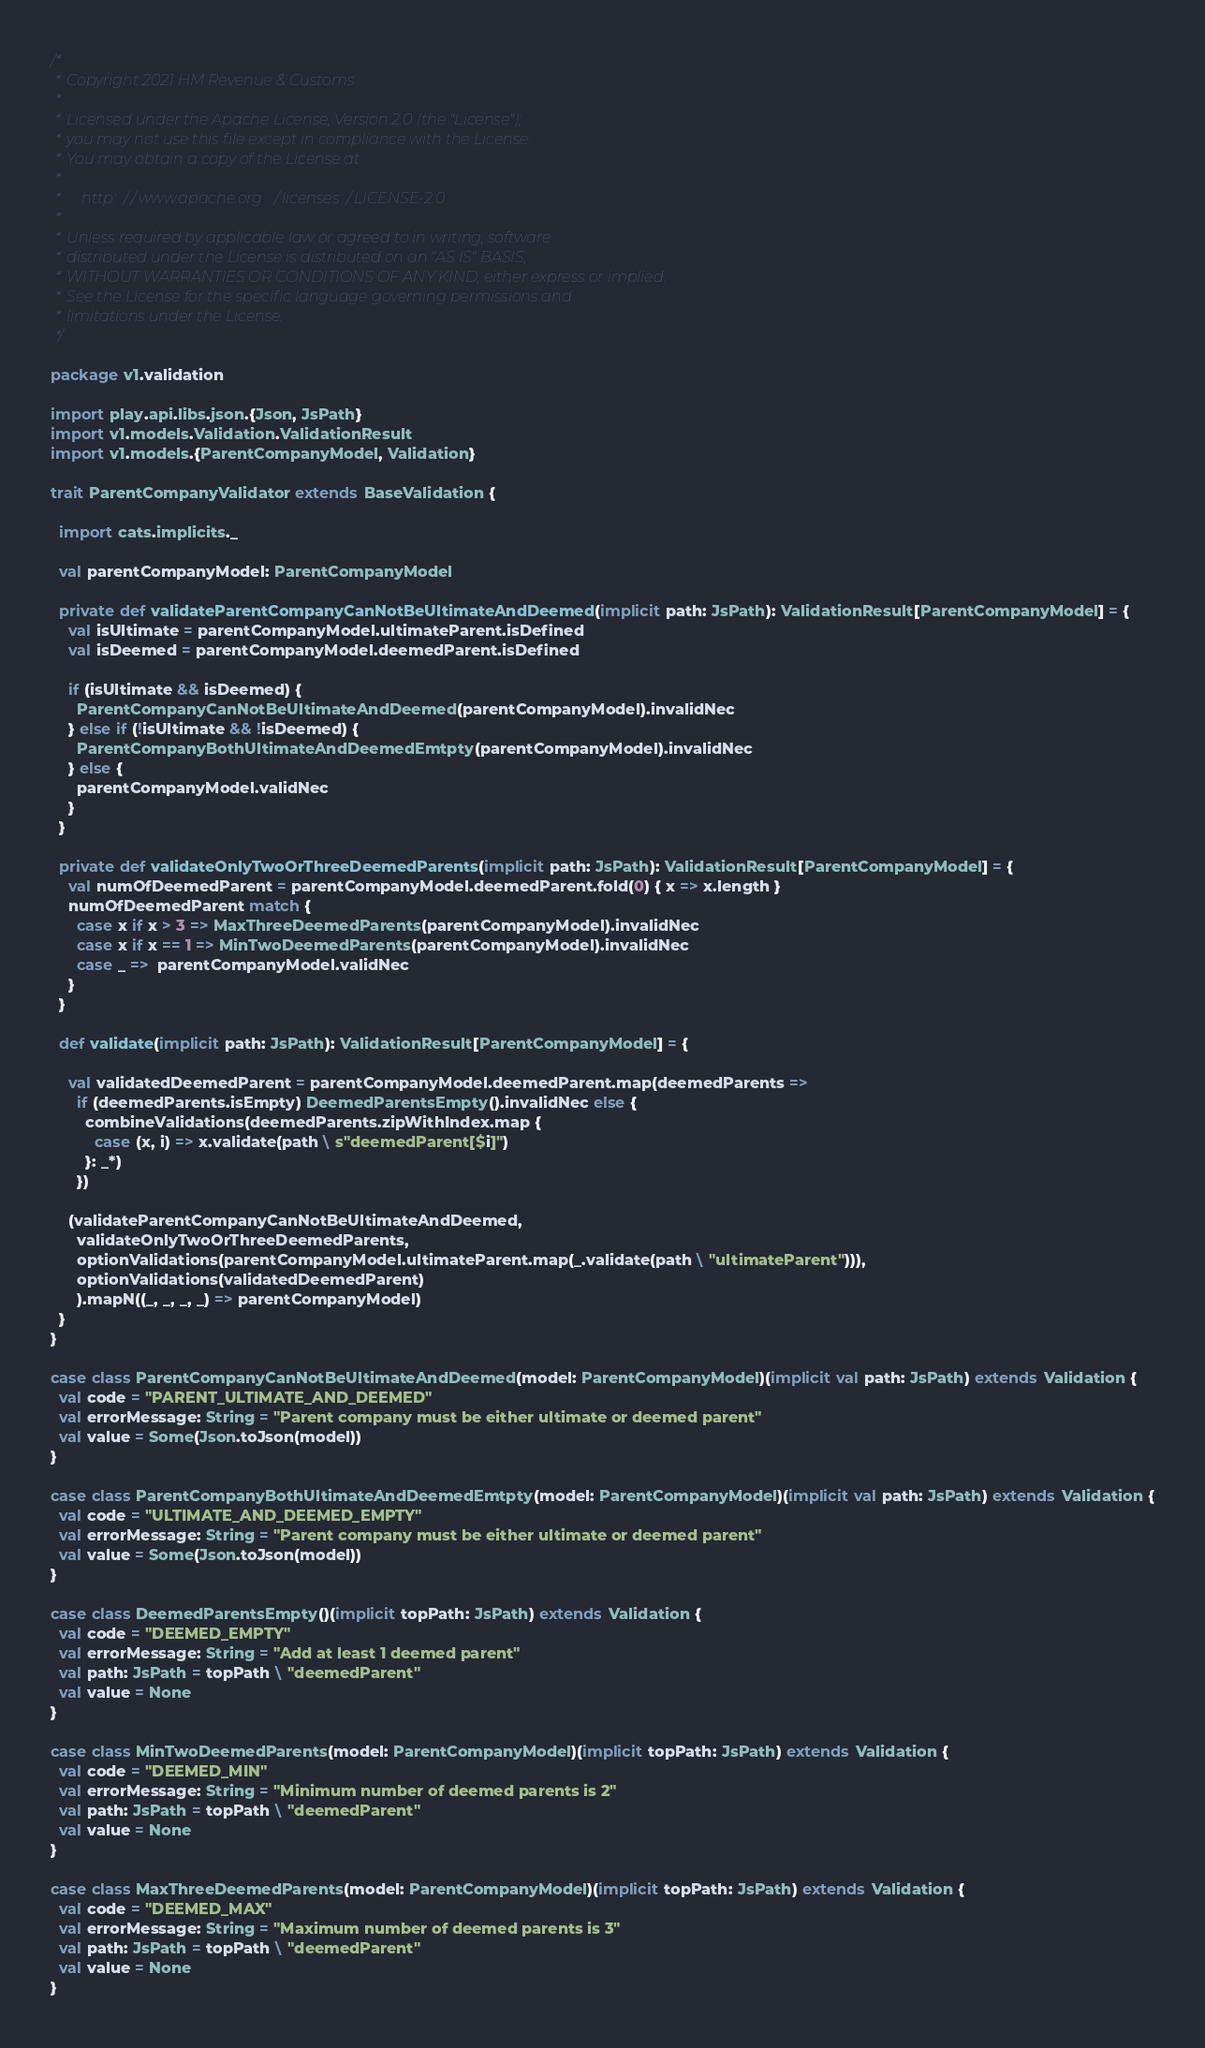Convert code to text. <code><loc_0><loc_0><loc_500><loc_500><_Scala_>/*
 * Copyright 2021 HM Revenue & Customs
 *
 * Licensed under the Apache License, Version 2.0 (the "License");
 * you may not use this file except in compliance with the License.
 * You may obtain a copy of the License at
 *
 *     http://www.apache.org/licenses/LICENSE-2.0
 *
 * Unless required by applicable law or agreed to in writing, software
 * distributed under the License is distributed on an "AS IS" BASIS,
 * WITHOUT WARRANTIES OR CONDITIONS OF ANY KIND, either express or implied.
 * See the License for the specific language governing permissions and
 * limitations under the License.
 */

package v1.validation

import play.api.libs.json.{Json, JsPath}
import v1.models.Validation.ValidationResult
import v1.models.{ParentCompanyModel, Validation}

trait ParentCompanyValidator extends BaseValidation {

  import cats.implicits._

  val parentCompanyModel: ParentCompanyModel

  private def validateParentCompanyCanNotBeUltimateAndDeemed(implicit path: JsPath): ValidationResult[ParentCompanyModel] = {
    val isUltimate = parentCompanyModel.ultimateParent.isDefined
    val isDeemed = parentCompanyModel.deemedParent.isDefined

    if (isUltimate && isDeemed) {
      ParentCompanyCanNotBeUltimateAndDeemed(parentCompanyModel).invalidNec
    } else if (!isUltimate && !isDeemed) {
      ParentCompanyBothUltimateAndDeemedEmtpty(parentCompanyModel).invalidNec
    } else {
      parentCompanyModel.validNec
    }
  }

  private def validateOnlyTwoOrThreeDeemedParents(implicit path: JsPath): ValidationResult[ParentCompanyModel] = {
    val numOfDeemedParent = parentCompanyModel.deemedParent.fold(0) { x => x.length }
    numOfDeemedParent match {
      case x if x > 3 => MaxThreeDeemedParents(parentCompanyModel).invalidNec
      case x if x == 1 => MinTwoDeemedParents(parentCompanyModel).invalidNec
      case _ =>  parentCompanyModel.validNec
    }
  }

  def validate(implicit path: JsPath): ValidationResult[ParentCompanyModel] = {

    val validatedDeemedParent = parentCompanyModel.deemedParent.map(deemedParents =>
      if (deemedParents.isEmpty) DeemedParentsEmpty().invalidNec else {
        combineValidations(deemedParents.zipWithIndex.map {
          case (x, i) => x.validate(path \ s"deemedParent[$i]")
        }: _*)
      })

    (validateParentCompanyCanNotBeUltimateAndDeemed,
      validateOnlyTwoOrThreeDeemedParents,
      optionValidations(parentCompanyModel.ultimateParent.map(_.validate(path \ "ultimateParent"))),
      optionValidations(validatedDeemedParent)
      ).mapN((_, _, _, _) => parentCompanyModel)
  }
}

case class ParentCompanyCanNotBeUltimateAndDeemed(model: ParentCompanyModel)(implicit val path: JsPath) extends Validation {
  val code = "PARENT_ULTIMATE_AND_DEEMED"
  val errorMessage: String = "Parent company must be either ultimate or deemed parent"
  val value = Some(Json.toJson(model))
}

case class ParentCompanyBothUltimateAndDeemedEmtpty(model: ParentCompanyModel)(implicit val path: JsPath) extends Validation {
  val code = "ULTIMATE_AND_DEEMED_EMPTY"
  val errorMessage: String = "Parent company must be either ultimate or deemed parent"
  val value = Some(Json.toJson(model))
}

case class DeemedParentsEmpty()(implicit topPath: JsPath) extends Validation {
  val code = "DEEMED_EMPTY"
  val errorMessage: String = "Add at least 1 deemed parent"
  val path: JsPath = topPath \ "deemedParent"
  val value = None
}

case class MinTwoDeemedParents(model: ParentCompanyModel)(implicit topPath: JsPath) extends Validation {
  val code = "DEEMED_MIN"
  val errorMessage: String = "Minimum number of deemed parents is 2"
  val path: JsPath = topPath \ "deemedParent"
  val value = None
}

case class MaxThreeDeemedParents(model: ParentCompanyModel)(implicit topPath: JsPath) extends Validation {
  val code = "DEEMED_MAX"
  val errorMessage: String = "Maximum number of deemed parents is 3"
  val path: JsPath = topPath \ "deemedParent"
  val value = None
}






</code> 